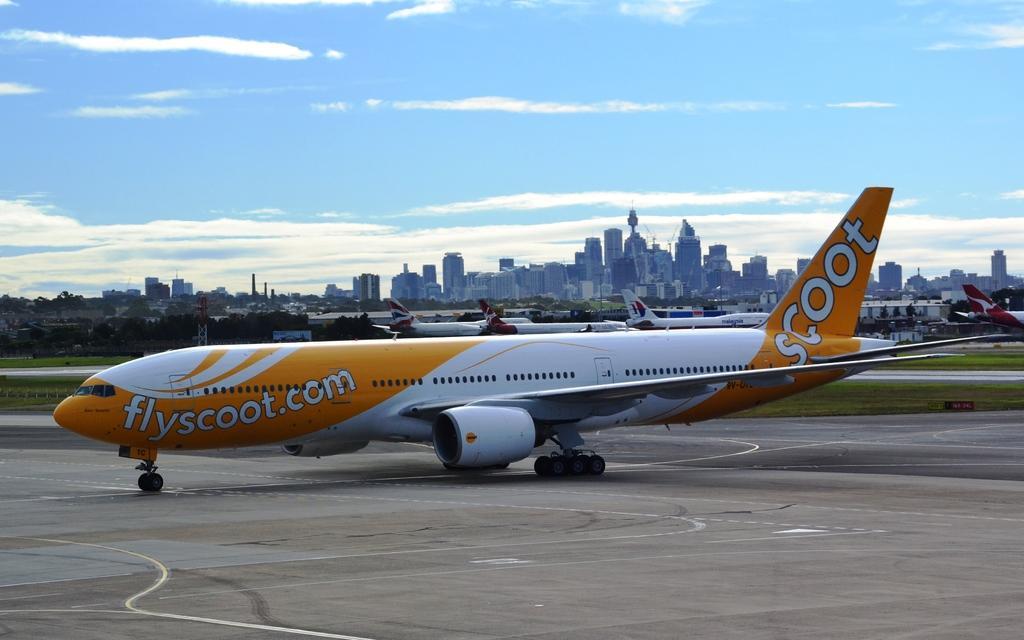Describe this image in one or two sentences. In this image in the center there is an airplane, and at the bottom there is walkway and grass. And in the background there are some trees, airplanes, buildings and some poles and at the top there is sky. 